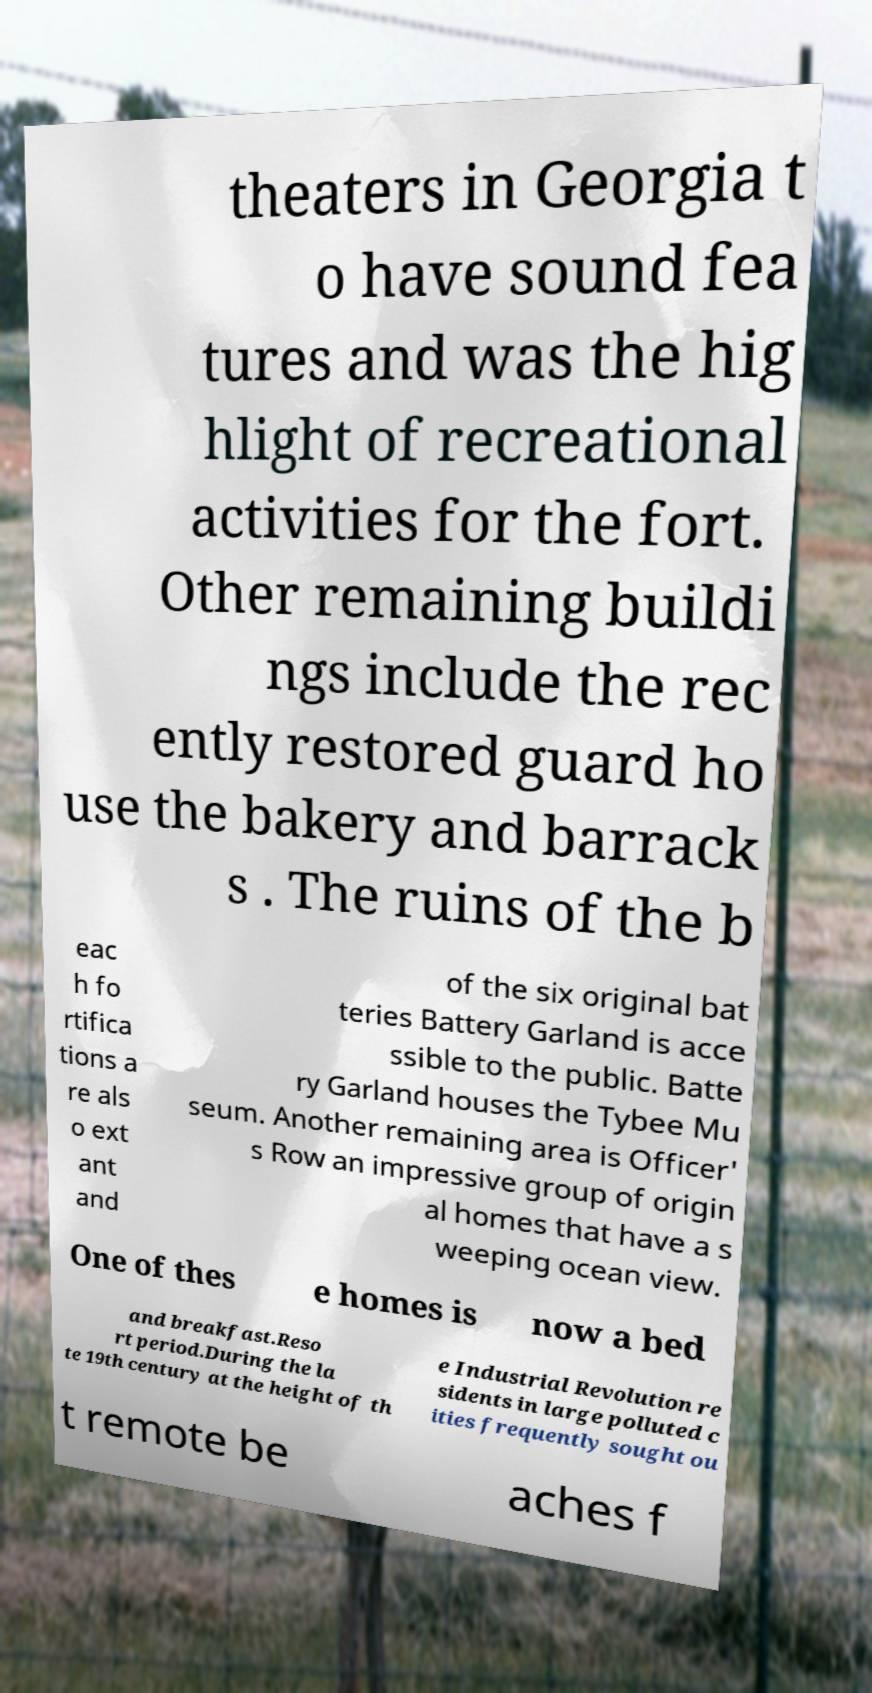Could you extract and type out the text from this image? theaters in Georgia t o have sound fea tures and was the hig hlight of recreational activities for the fort. Other remaining buildi ngs include the rec ently restored guard ho use the bakery and barrack s . The ruins of the b eac h fo rtifica tions a re als o ext ant and of the six original bat teries Battery Garland is acce ssible to the public. Batte ry Garland houses the Tybee Mu seum. Another remaining area is Officer' s Row an impressive group of origin al homes that have a s weeping ocean view. One of thes e homes is now a bed and breakfast.Reso rt period.During the la te 19th century at the height of th e Industrial Revolution re sidents in large polluted c ities frequently sought ou t remote be aches f 